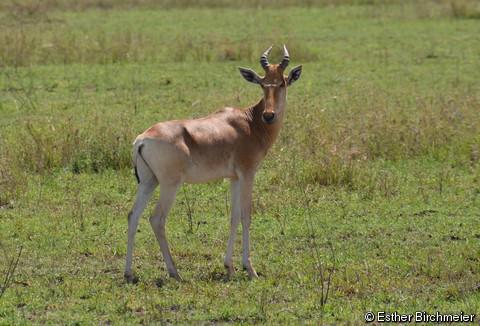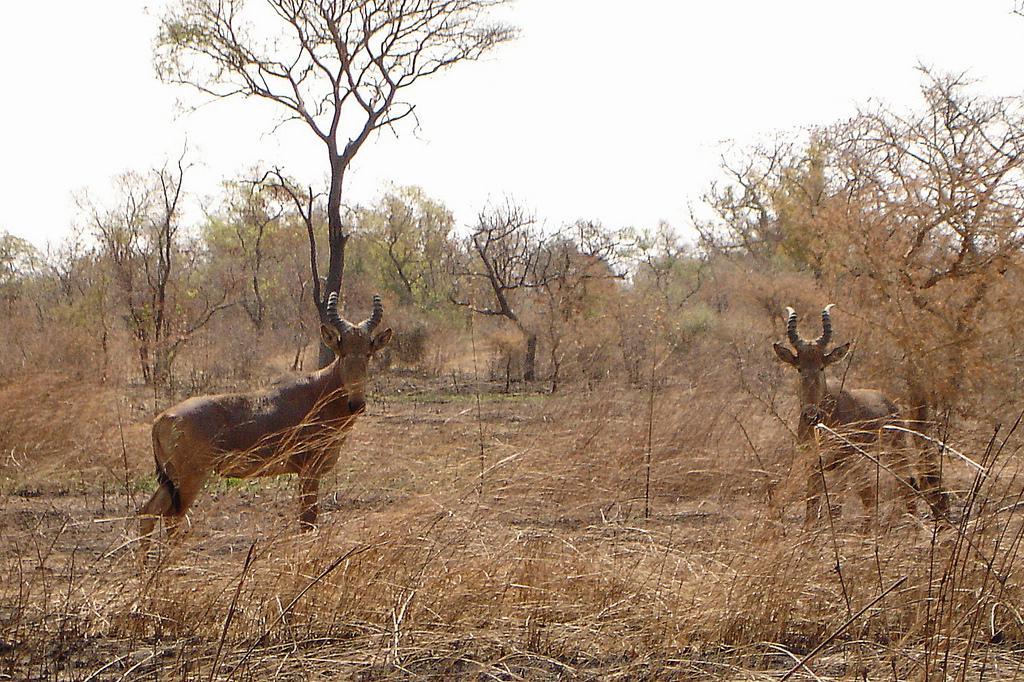The first image is the image on the left, the second image is the image on the right. Evaluate the accuracy of this statement regarding the images: "Each image contains just one horned animal, and the animals' faces and bodies are turned in different directions.". Is it true? Answer yes or no. No. The first image is the image on the left, the second image is the image on the right. Given the left and right images, does the statement "One of the animals is standing in left profile." hold true? Answer yes or no. No. 